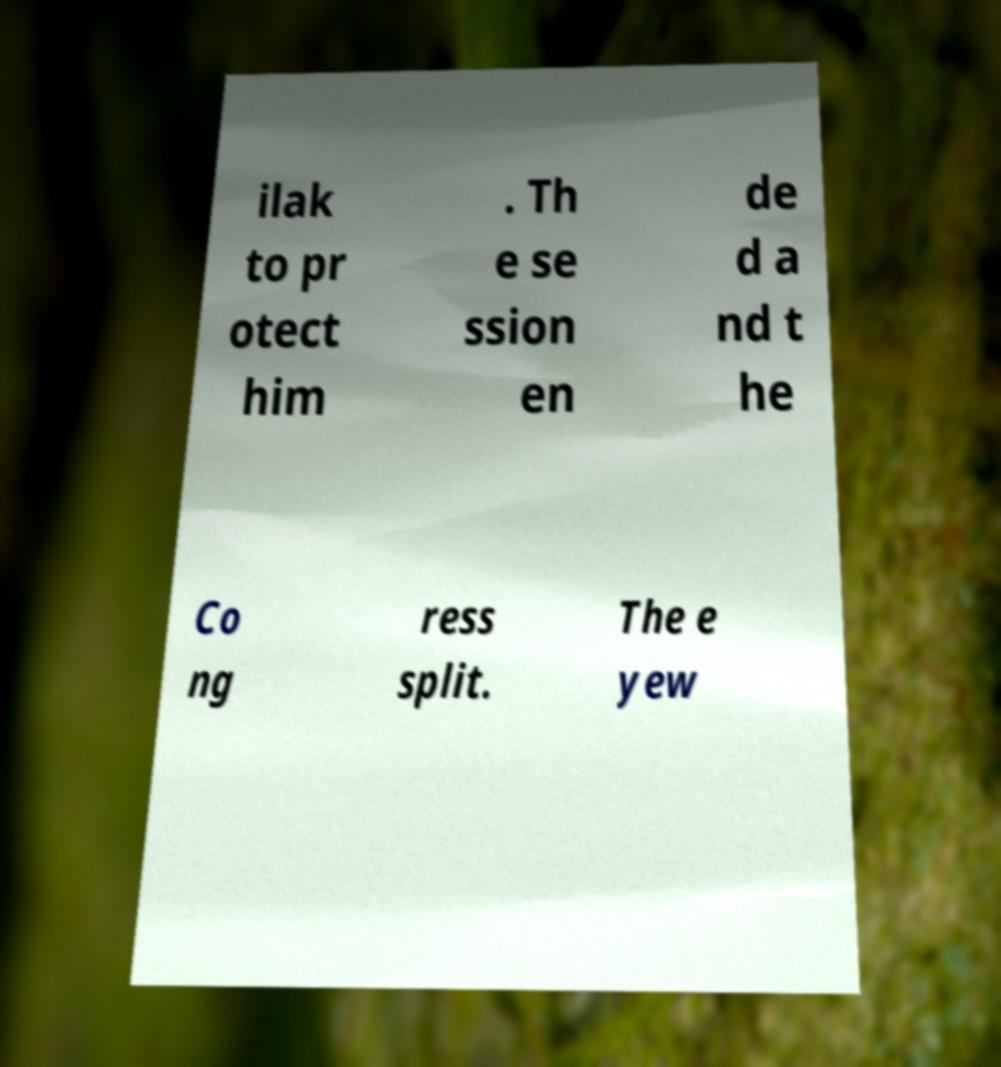For documentation purposes, I need the text within this image transcribed. Could you provide that? ilak to pr otect him . Th e se ssion en de d a nd t he Co ng ress split. The e yew 